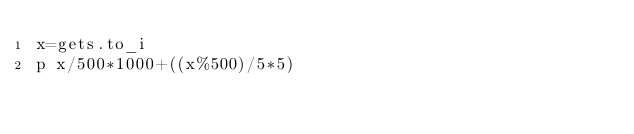Convert code to text. <code><loc_0><loc_0><loc_500><loc_500><_Ruby_>x=gets.to_i
p x/500*1000+((x%500)/5*5)</code> 